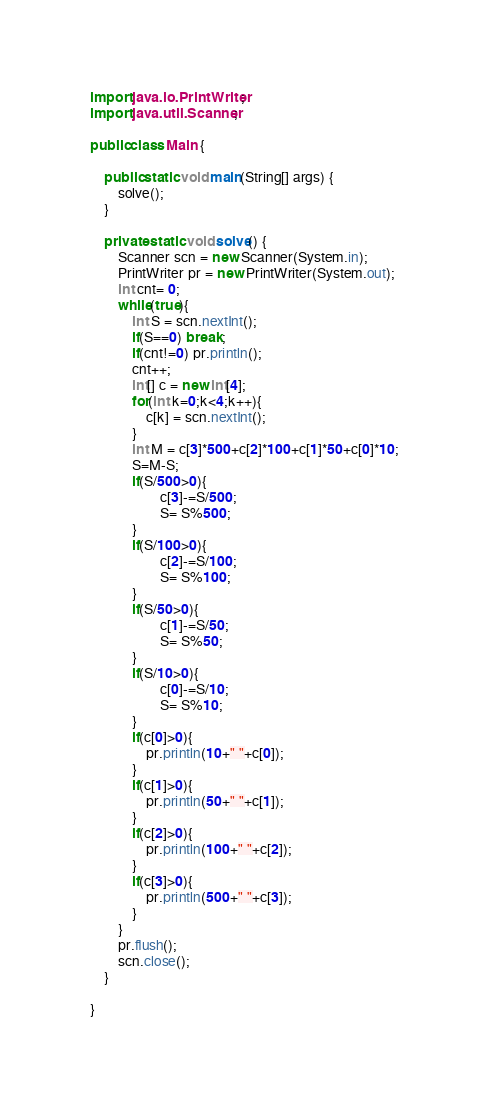<code> <loc_0><loc_0><loc_500><loc_500><_Java_>import java.io.PrintWriter;
import java.util.Scanner;

public class Main {

	public static void main(String[] args) {
		solve();
	}

	private static void solve() {
		Scanner scn = new Scanner(System.in);
		PrintWriter pr = new PrintWriter(System.out);
		int cnt= 0;
		while(true){
			int S = scn.nextInt();
			if(S==0) break;
			if(cnt!=0) pr.println();
			cnt++;
			int[] c = new int[4];
			for(int k=0;k<4;k++){
				c[k] = scn.nextInt();
			}
			int M = c[3]*500+c[2]*100+c[1]*50+c[0]*10;
			S=M-S;
			if(S/500>0){
					c[3]-=S/500;
					S= S%500;
			}
			if(S/100>0){
					c[2]-=S/100;
					S= S%100;
			}
			if(S/50>0){
					c[1]-=S/50;
					S= S%50;
			}
			if(S/10>0){
					c[0]-=S/10;
					S= S%10;
			}
			if(c[0]>0){
				pr.println(10+" "+c[0]);
			}
			if(c[1]>0){
				pr.println(50+" "+c[1]);
			}
			if(c[2]>0){
				pr.println(100+" "+c[2]);
			}
			if(c[3]>0){
				pr.println(500+" "+c[3]);
			}
		}
		pr.flush();
		scn.close();
	}

}</code> 